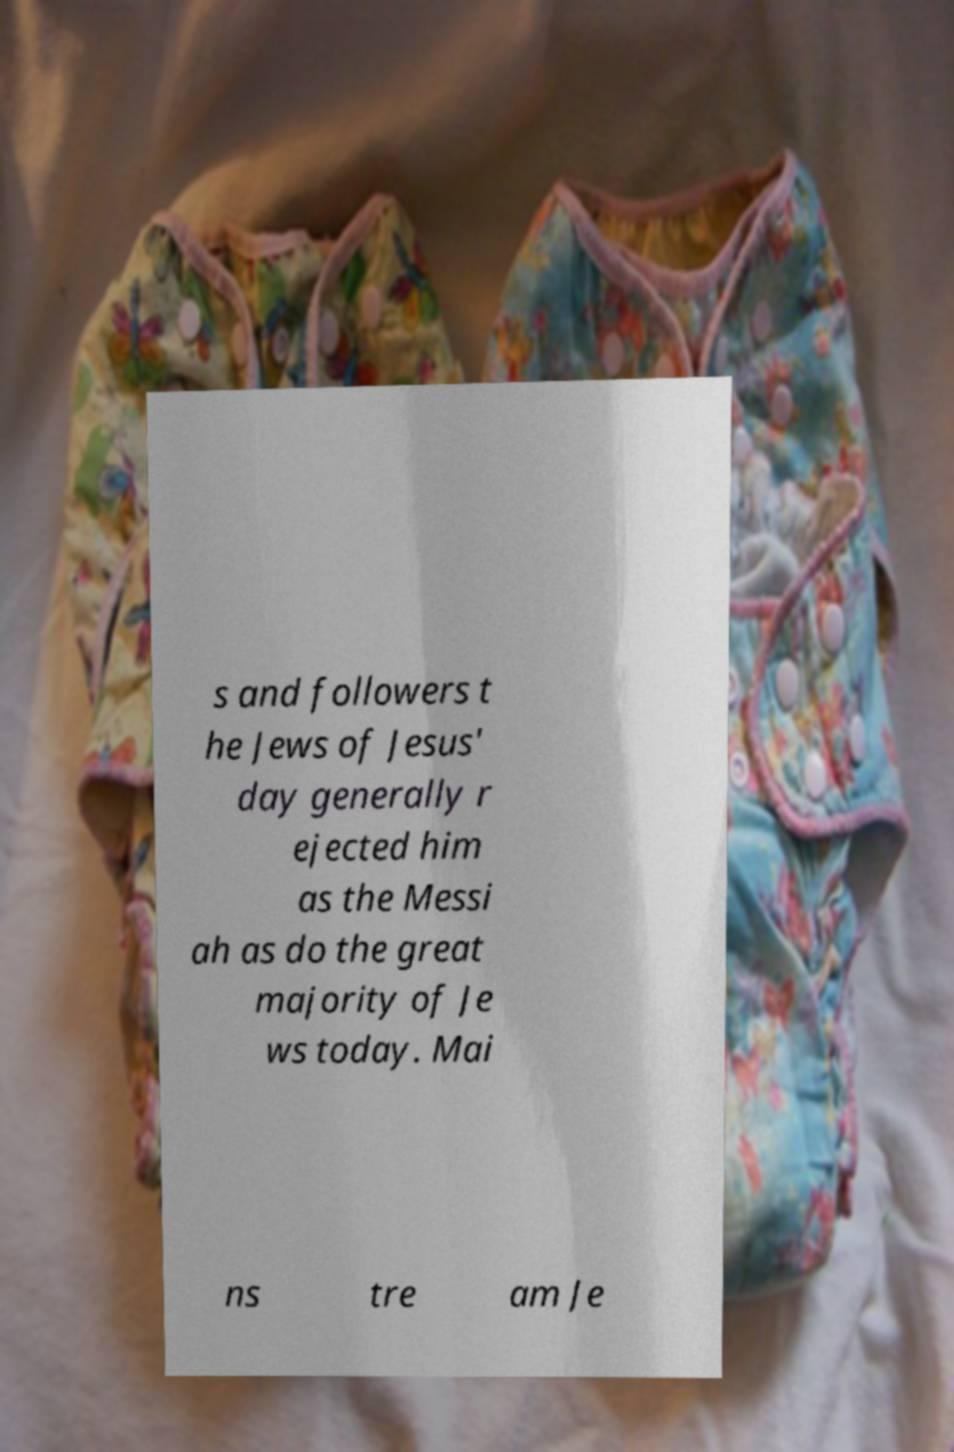I need the written content from this picture converted into text. Can you do that? s and followers t he Jews of Jesus' day generally r ejected him as the Messi ah as do the great majority of Je ws today. Mai ns tre am Je 